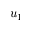<formula> <loc_0><loc_0><loc_500><loc_500>u _ { 1 }</formula> 